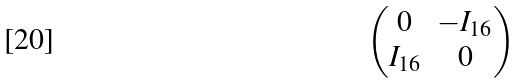<formula> <loc_0><loc_0><loc_500><loc_500>\begin{pmatrix} 0 & - I _ { 1 6 } \\ I _ { 1 6 } & 0 \end{pmatrix}</formula> 